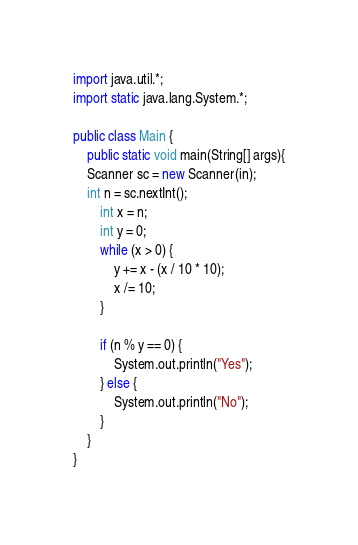Convert code to text. <code><loc_0><loc_0><loc_500><loc_500><_Java_>import java.util.*;
import static java.lang.System.*;

public class Main {
	public static void main(String[] args){
    Scanner sc = new Scanner(in);
    int n = sc.nextInt();
		int x = n;
		int y = 0;
		while (x > 0) {
			y += x - (x / 10 * 10);
			x /= 10;
		}

		if (n % y == 0) {
			System.out.println("Yes");
		} else {
			System.out.println("No");
		}
	}
}
</code> 